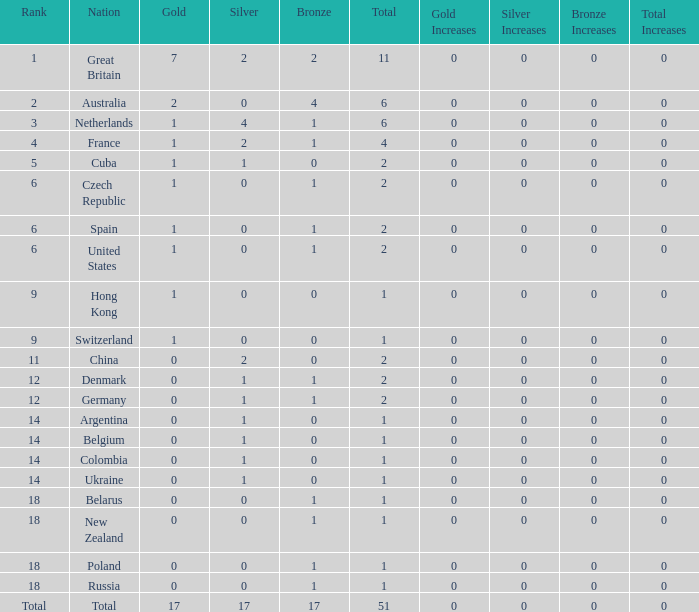Tell me the lowest gold for rank of 6 and total less than 2 None. 